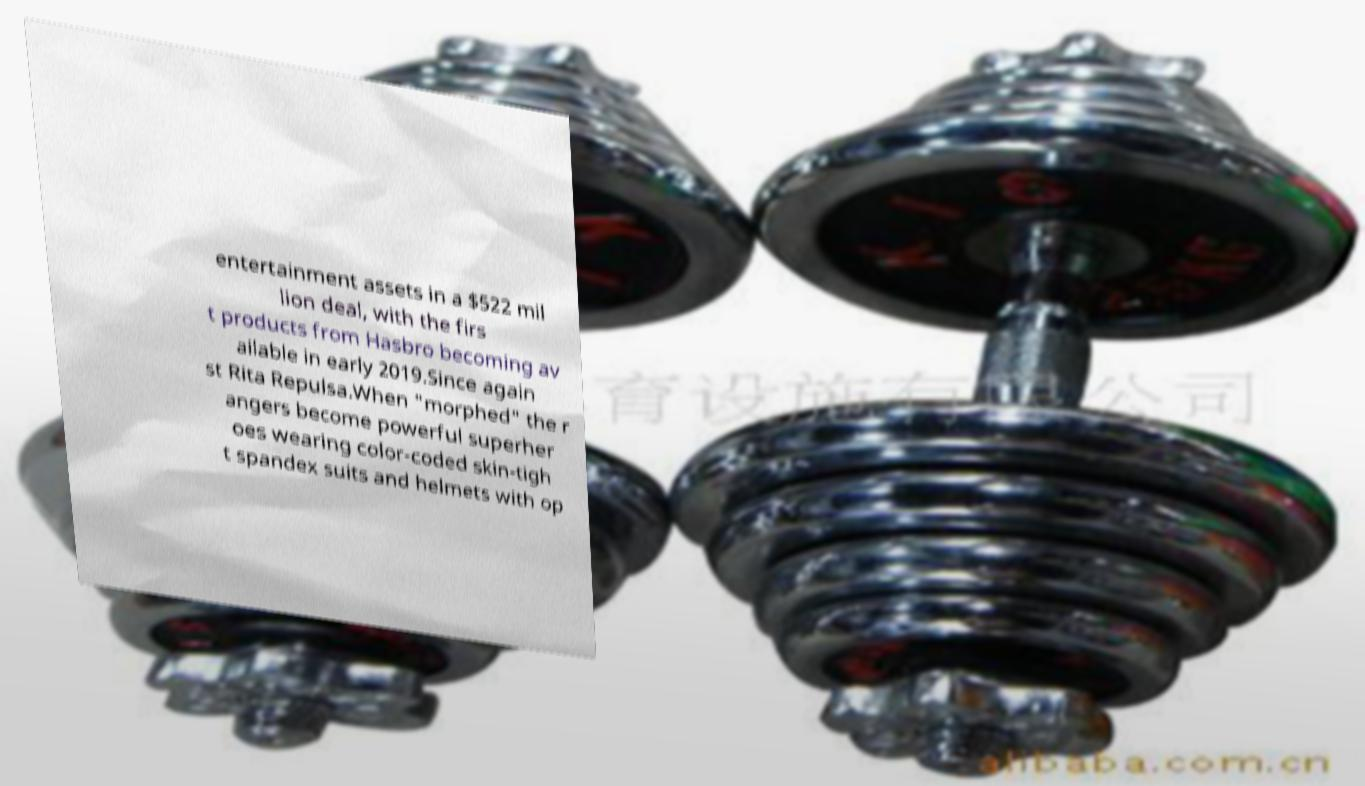I need the written content from this picture converted into text. Can you do that? entertainment assets in a $522 mil lion deal, with the firs t products from Hasbro becoming av ailable in early 2019.Since again st Rita Repulsa.When "morphed" the r angers become powerful superher oes wearing color-coded skin-tigh t spandex suits and helmets with op 